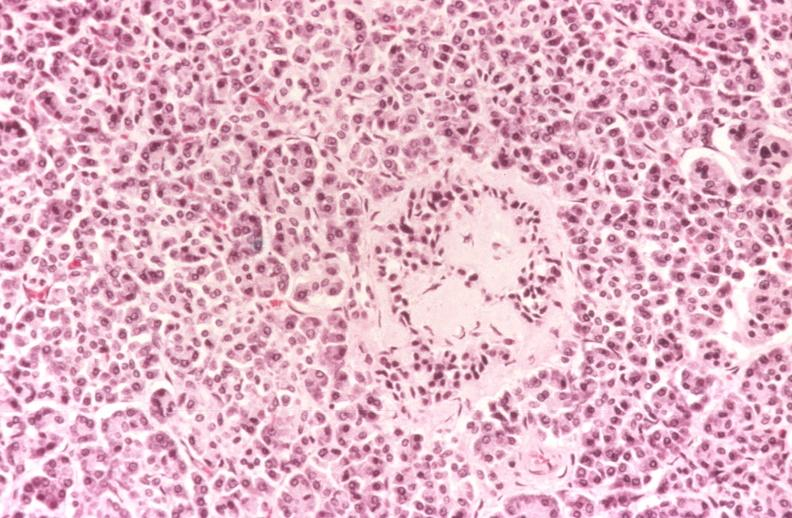s leukocytes present?
Answer the question using a single word or phrase. No 